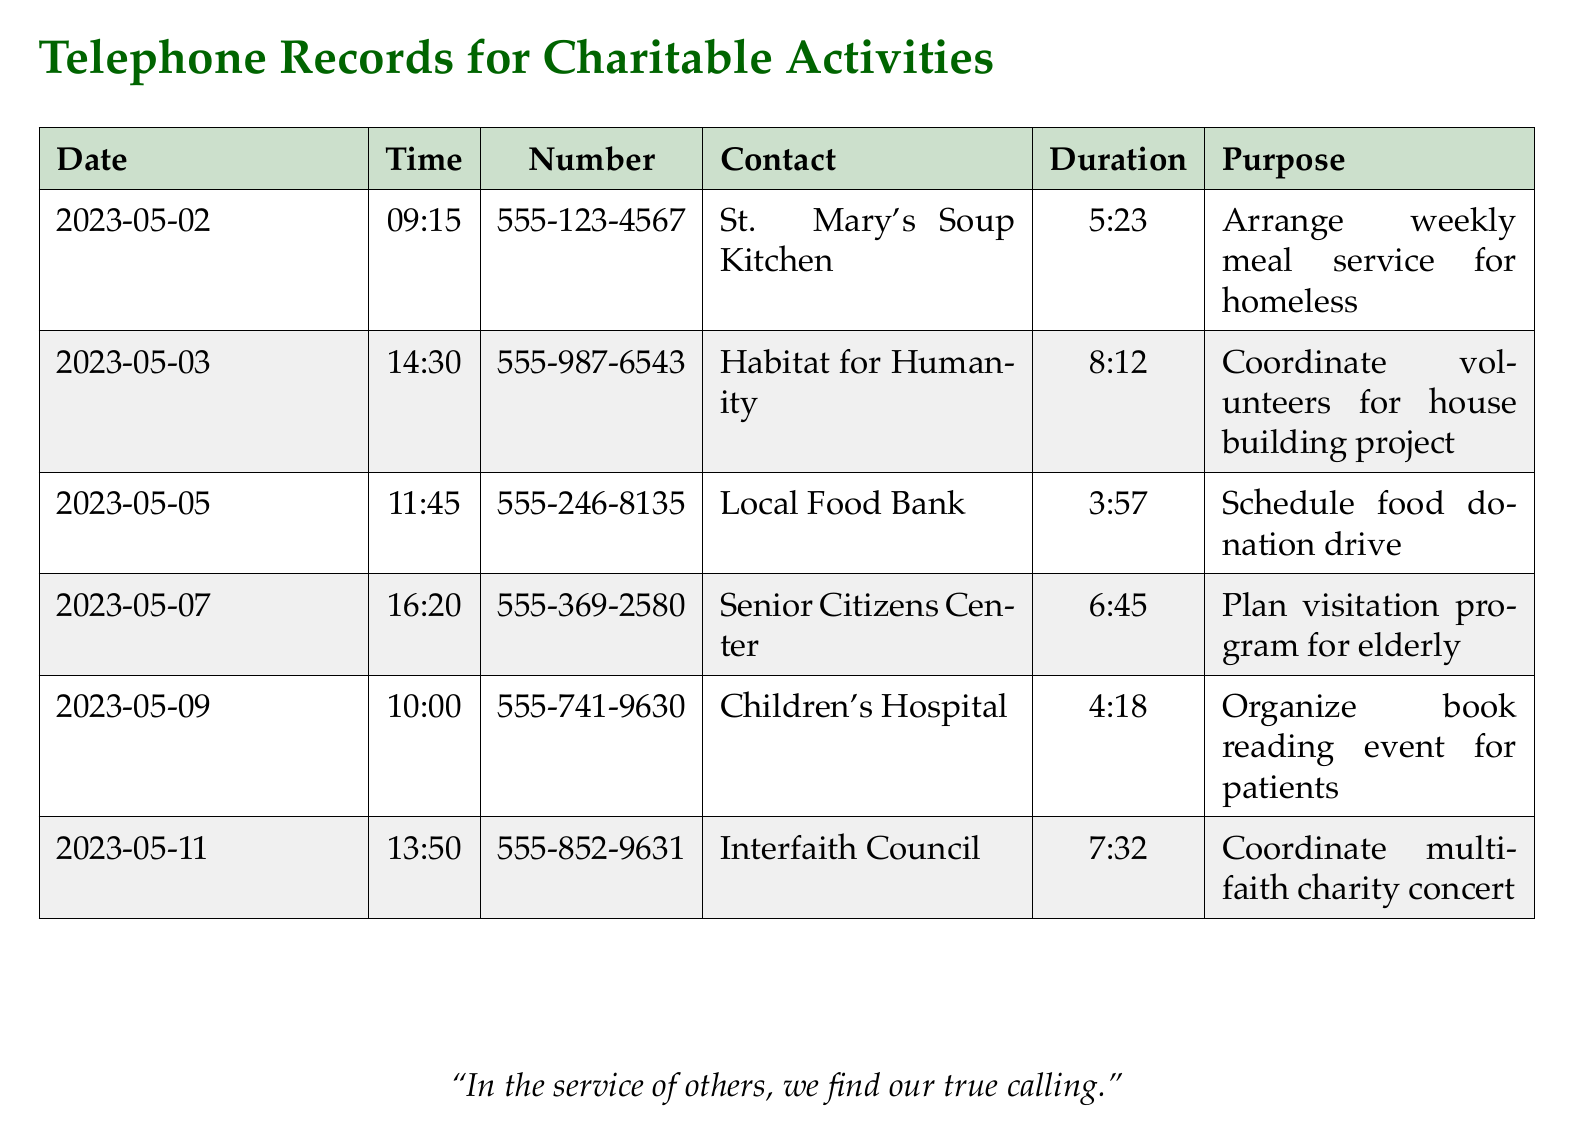What is the first date of the call records? The first date in the record is provided in the first row of the table.
Answer: 2023-05-02 What is the purpose of the call on May 7th? The purpose for the call on May 7th can be found in the corresponding row for that date.
Answer: Plan visitation program for elderly How long did the call to the Local Food Bank last? The duration of the call with the Local Food Bank is listed in the duration column in the corresponding row.
Answer: 3:57 What is the contact organization for the call on May 9th? The contact organization can be found by looking at the row for May 9th and checking the contact column.
Answer: Children's Hospital Which call took the longest time? Determining the longest call requires comparing all durations listed in the document.
Answer: Habitat for Humanity How many calls were made to organizations with "center" in their name? To find this number, count the rows with "center" in the contact column.
Answer: 2 What type of event was organized in collaboration with the Interfaith Council? The event organized is specified under the purpose for the call made to Interfaith Council.
Answer: Multi-faith charity concert What day was the call made to arrange a food donation drive? The day of the call to schedule the food donation drive is noted in the records under the date column.
Answer: May 5 What time was the call made to St. Mary's Soup Kitchen? The time of the call is provided in the respective column for the call recorded with St. Mary's Soup Kitchen.
Answer: 09:15 